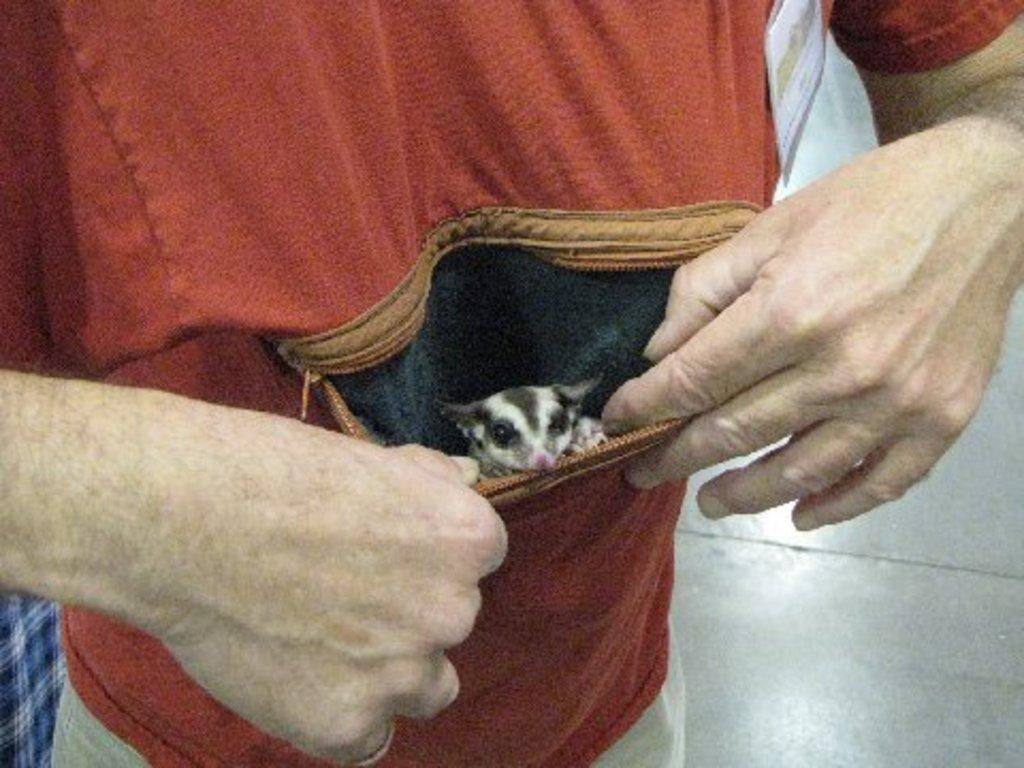Who is the main subject in the image? There is a person in the center of the image. Can you describe any additional details about the person? There is a mouse in the person's pocket. What type of care does the person need in the image? There is no indication in the image that the person needs any care. 